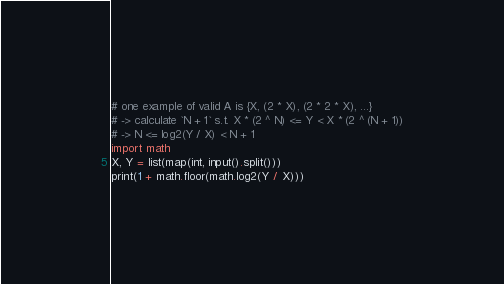Convert code to text. <code><loc_0><loc_0><loc_500><loc_500><_Python_># one example of valid A is {X, (2 * X), (2 * 2 * X), ...}
# -> calculate `N + 1` s.t. X * (2 ^ N) <= Y < X * (2 ^ (N + 1))
# -> N <= log2(Y / X) < N + 1
import math
X, Y = list(map(int, input().split()))
print(1 + math.floor(math.log2(Y / X)))</code> 